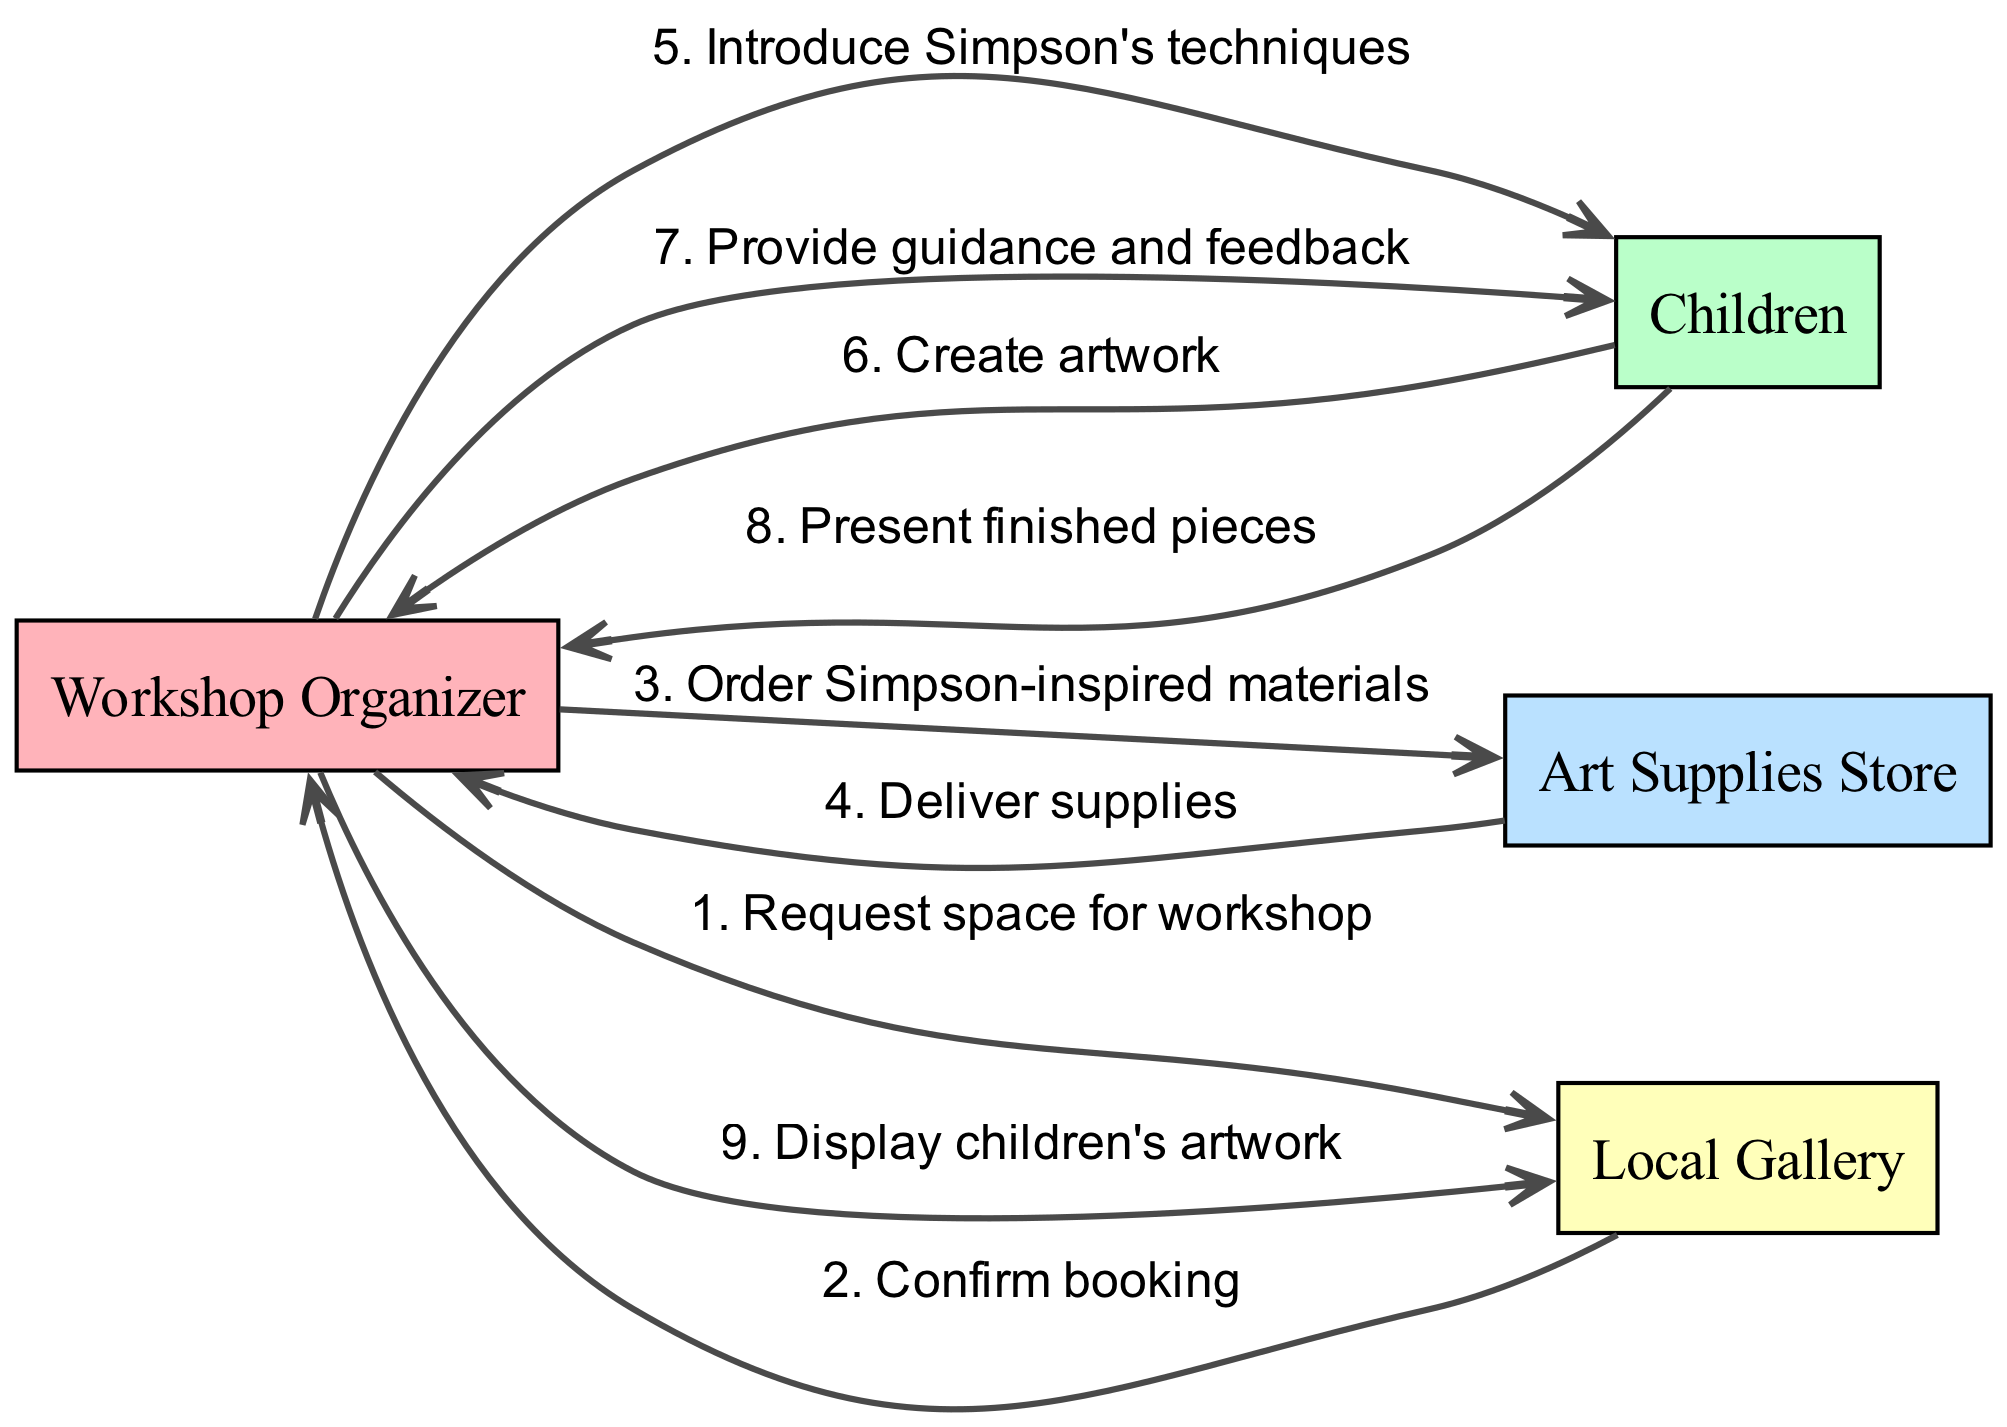What is the first step in the sequence? The first step in the sequence is the "Request space for workshop" sent from the "Workshop Organizer" to the "Local Gallery." This indicates the initial action to secure a venue for the workshop.
Answer: Request space for workshop How many actors are involved in the workshop sequence? There are four actors involved in the workshop sequence: "Workshop Organizer," "Children," "Art Supplies Store," and "Local Gallery." This total includes all parties interacting in the diagram.
Answer: Four What is the last action performed in the sequence? The last action performed in the sequence is "Display children's artwork" from the "Workshop Organizer" to the "Local Gallery." This shows the completion of the workshop's outcomes.
Answer: Display children's artwork Which actor provides guidance and feedback? The "Workshop Organizer" provides guidance and feedback to the "Children." This interaction reflects the support role the organizer plays during the workshop.
Answer: Workshop Organizer What is the relationship between the "Art Supplies Store" and "Workshop Organizer"? The relationship between the "Art Supplies Store" and "Workshop Organizer" is that the organizer places an order for materials, which results in the delivery of supplies. This flow showcases the supply chain aspect of the workshop.
Answer: Order Simpson-inspired materials How many messages are exchanged between the "Workshop Organizer" and "Local Gallery"? There are two messages exchanged between the "Workshop Organizer" and "Local Gallery." The first is a request to book the space, and the second is a confirmation of the booking. This reflects the communication needed to secure the workshop location.
Answer: Two Which actor interacts with the children after they create artwork? The "Workshop Organizer" interacts with the children after they create artwork by providing guidance and feedback. This interaction emphasizes the role of mentorship in the workshop.
Answer: Workshop Organizer What is the purpose of the message "Order Simpson-inspired materials"? The purpose of the message "Order Simpson-inspired materials" is to acquire specific art supplies for the workshop that are inspired by Michael Simpson's techniques, ensuring the workshop aligns with the artistic theme.
Answer: Acquire specific art supplies What indicates the completion of the children's artwork presentation? The message "Present finished pieces" from the "Children" to the "Workshop Organizer" indicates the completion of the children's artwork presentation. This signifies the culmination of the workshop activities.
Answer: Present finished pieces 